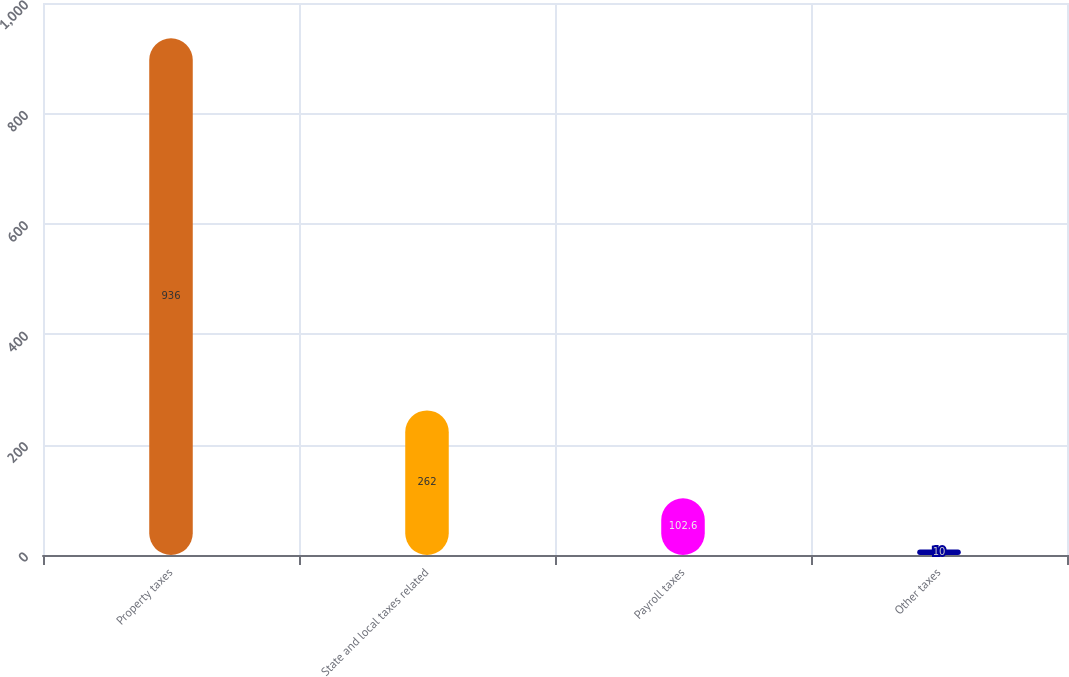Convert chart to OTSL. <chart><loc_0><loc_0><loc_500><loc_500><bar_chart><fcel>Property taxes<fcel>State and local taxes related<fcel>Payroll taxes<fcel>Other taxes<nl><fcel>936<fcel>262<fcel>102.6<fcel>10<nl></chart> 